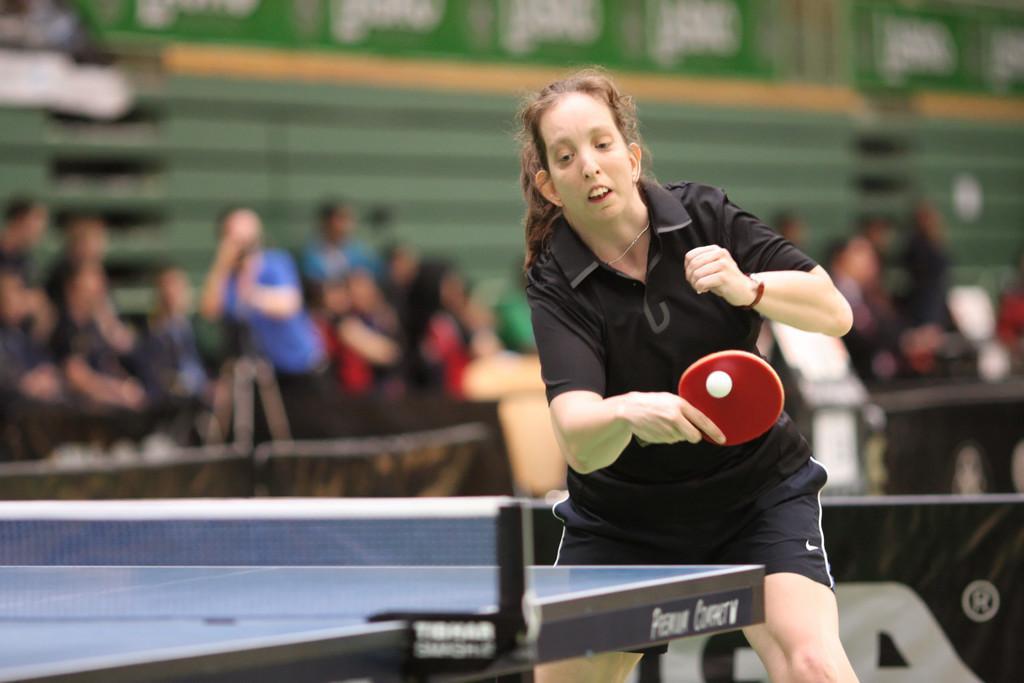How would you summarize this image in a sentence or two? This is a picture is a woman in black dress holding a red bag. In front of the there is a table background of the women there are the group of people sitting. 